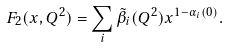<formula> <loc_0><loc_0><loc_500><loc_500>F _ { 2 } ( x , Q ^ { 2 } ) = \sum _ { i } \tilde { \beta } _ { i } ( Q ^ { 2 } ) x ^ { 1 - \alpha _ { i } ( 0 ) } .</formula> 